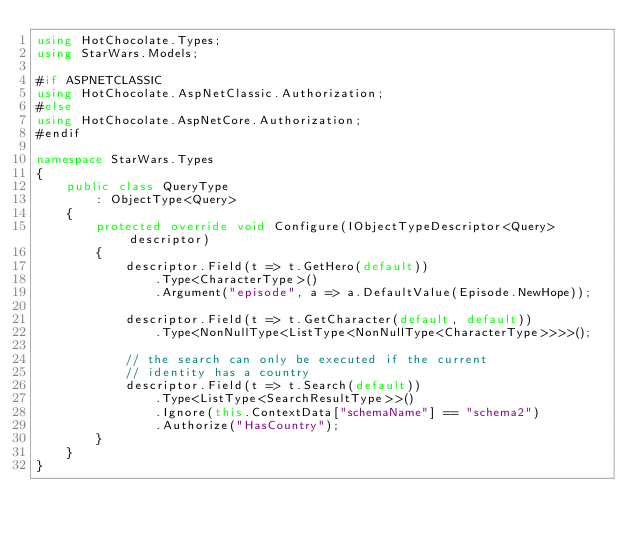<code> <loc_0><loc_0><loc_500><loc_500><_C#_>using HotChocolate.Types;
using StarWars.Models;

#if ASPNETCLASSIC
using HotChocolate.AspNetClassic.Authorization;
#else
using HotChocolate.AspNetCore.Authorization;
#endif

namespace StarWars.Types
{
    public class QueryType
        : ObjectType<Query>
    {
        protected override void Configure(IObjectTypeDescriptor<Query> descriptor)
        {
            descriptor.Field(t => t.GetHero(default))
                .Type<CharacterType>()
                .Argument("episode", a => a.DefaultValue(Episode.NewHope));

            descriptor.Field(t => t.GetCharacter(default, default))
                .Type<NonNullType<ListType<NonNullType<CharacterType>>>>();

            // the search can only be executed if the current
            // identity has a country
            descriptor.Field(t => t.Search(default))
                .Type<ListType<SearchResultType>>()
                .Ignore(this.ContextData["schemaName"] == "schema2")
                .Authorize("HasCountry");
        }
    }
}
</code> 